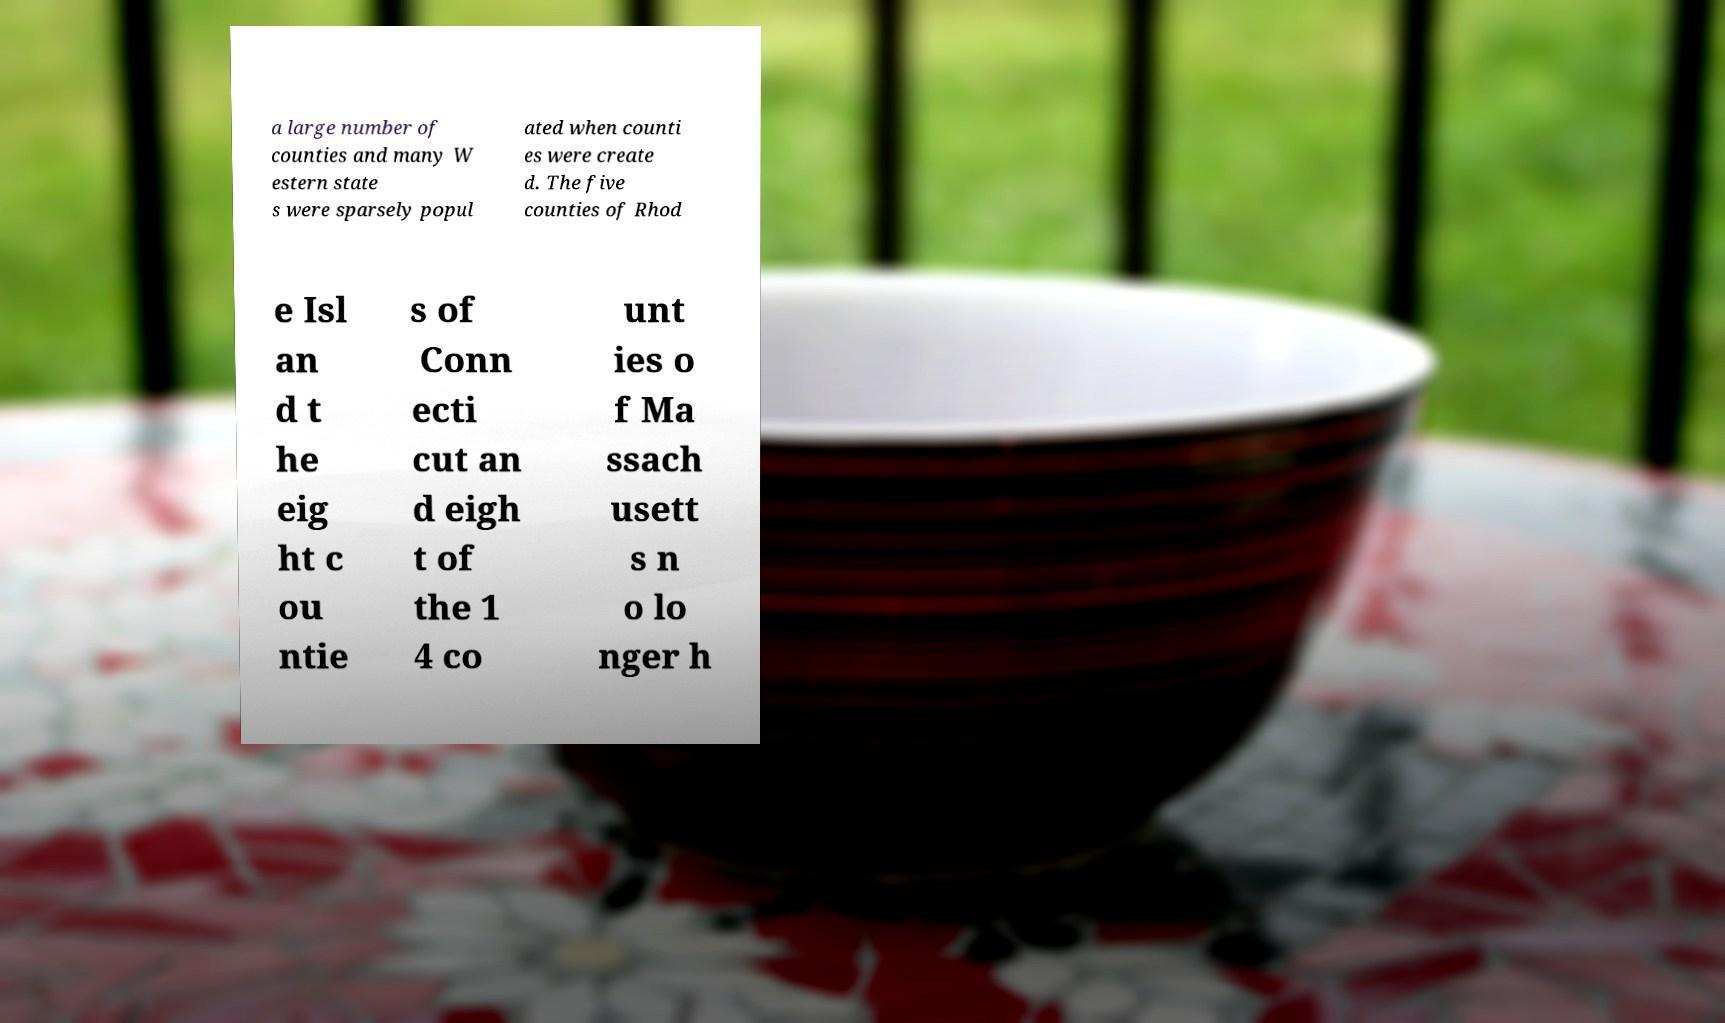Please identify and transcribe the text found in this image. a large number of counties and many W estern state s were sparsely popul ated when counti es were create d. The five counties of Rhod e Isl an d t he eig ht c ou ntie s of Conn ecti cut an d eigh t of the 1 4 co unt ies o f Ma ssach usett s n o lo nger h 